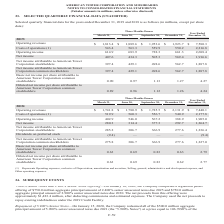According to American Tower Corporation's financial document, What does the cost of operations represent? Represents Operating expenses, exclusive of Depreciation, amortization and accretion, Selling, general, administrative and development expense, and Other operating expenses.. The document states: "______________ (1) Represents Operating expenses, exclusive of Depreciation, amortization and accretion, Selling, general, administrative and developm..." Also, What was the net income at the end of March 31? According to the financial document, 280.3 (in millions). The relevant text states: "Net income 280.3 314.4 377.3 292.7 1,264.7..." Also, What was the operating income at the end of June 30? According to the financial document, 546.0 (in millions). The relevant text states: "560.3 556.7 540.9 2,177.8 Operating income 402.9 546.0 567.2 388.9 1,905.0..." Also, How many quarters had operating revenues that was below $2,000 million? Counting the relevant items in the document: March, June, September, I find 3 instances. The key data points involved are: June, March, September. Also, can you calculate: What was the change in Operating revenues between Three Months Ended March and June? Based on the calculation: $1,780.9-$1,741.8, the result is 39.1 (in millions). This is based on the information: "2018: Operating revenues $ 1,741.8 $ 1,780.9 $ 1,785.5 $ 2,131.9 $ 7,440.1 2018: Operating revenues $ 1,741.8 $ 1,780.9 $ 1,785.5 $ 2,131.9 $ 7,440.1..." The key data points involved are: 1,741.8, 1,780.9. Also, can you calculate: What was the percentage change in operating revenues between Three Months Ended  September and December? To answer this question, I need to perform calculations using the financial data. The calculation is: ($2,131.9-$1,785.5)/$1,785.5, which equals 19.4 (percentage). This is based on the information: "2018: Operating revenues $ 1,741.8 $ 1,780.9 $ 1,785.5 $ 2,131.9 $ 7,440.1 perating revenues $ 1,741.8 $ 1,780.9 $ 1,785.5 $ 2,131.9 $ 7,440.1..." The key data points involved are: 1,785.5, 2,131.9. 